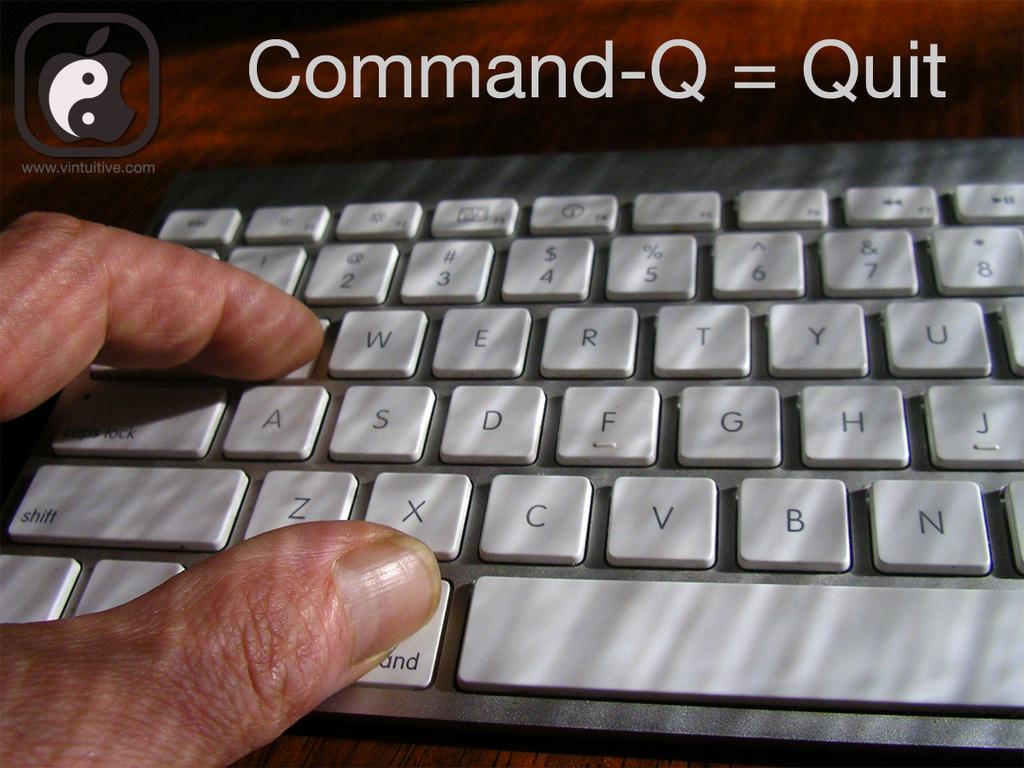What does command-q equal?
Keep it short and to the point. Quit. What key is above the "d" key?
Ensure brevity in your answer.  E. 